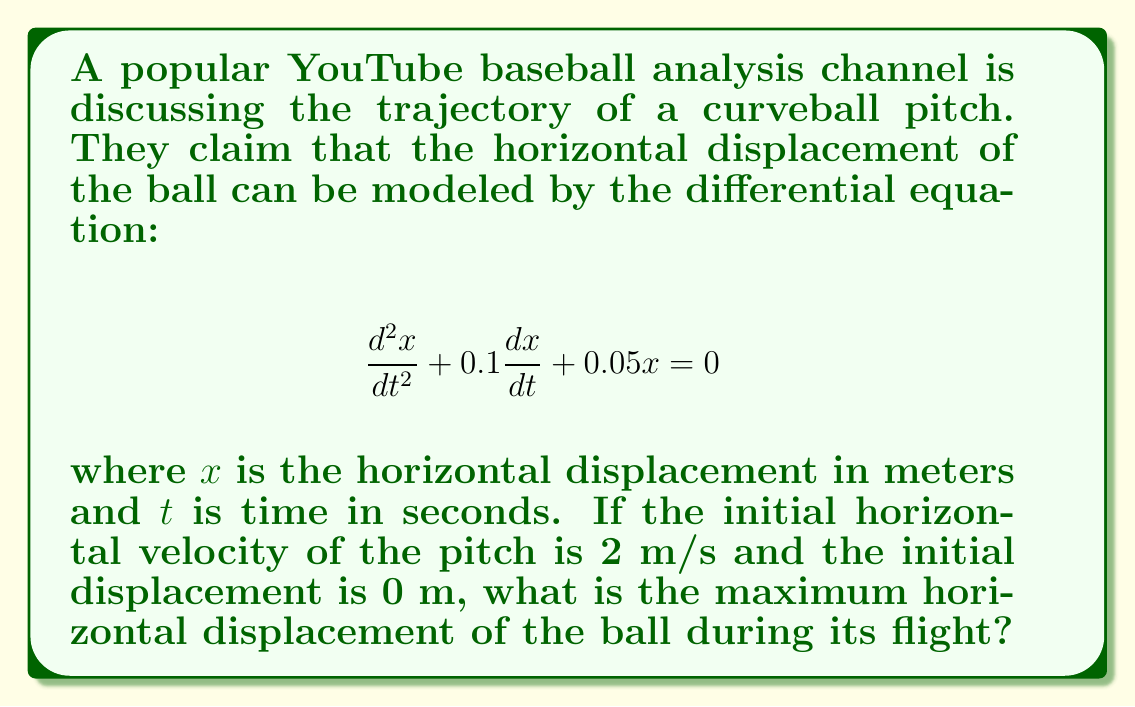Give your solution to this math problem. Let's approach this step-by-step:

1) First, we need to solve the given differential equation. The general solution for this type of equation is:

   $$x(t) = e^{-\alpha t}(A\cos(\beta t) + B\sin(\beta t))$$

   where $\alpha = 0.05$ and $\beta = \sqrt{0.05 - 0.05^2} \approx 0.2179$

2) We have two initial conditions:
   $x(0) = 0$ (initial displacement)
   $\frac{dx}{dt}(0) = 2$ (initial velocity)

3) Applying the first condition:
   $0 = A$

4) For the second condition, we differentiate $x(t)$:
   $$\frac{dx}{dt} = -\alpha e^{-\alpha t}(A\cos(\beta t) + B\sin(\beta t)) + e^{-\alpha t}(-A\beta\sin(\beta t) + B\beta\cos(\beta t))$$

   At $t=0$, this should equal 2:
   $$2 = -\alpha A + B\beta$$

   Since $A=0$, we have:
   $$B = \frac{2}{\beta} \approx 9.1785$$

5) So our solution is:
   $$x(t) = 9.1785e^{-0.05t}\sin(0.2179t)$$

6) To find the maximum displacement, we differentiate and set to zero:
   $$\frac{dx}{dt} = 9.1785e^{-0.05t}(0.2179\cos(0.2179t) - 0.05\sin(0.2179t)) = 0$$

7) This occurs when:
   $$\tan(0.2179t) = \frac{0.2179}{0.05} \approx 4.358$$

8) The first positive solution to this is:
   $$t \approx 5.7516 \text{ seconds}$$

9) Plugging this back into our solution for $x(t)$:
   $$x(5.7516) \approx 7.3852 \text{ meters}$$

This is the maximum horizontal displacement.
Answer: 7.3852 meters 